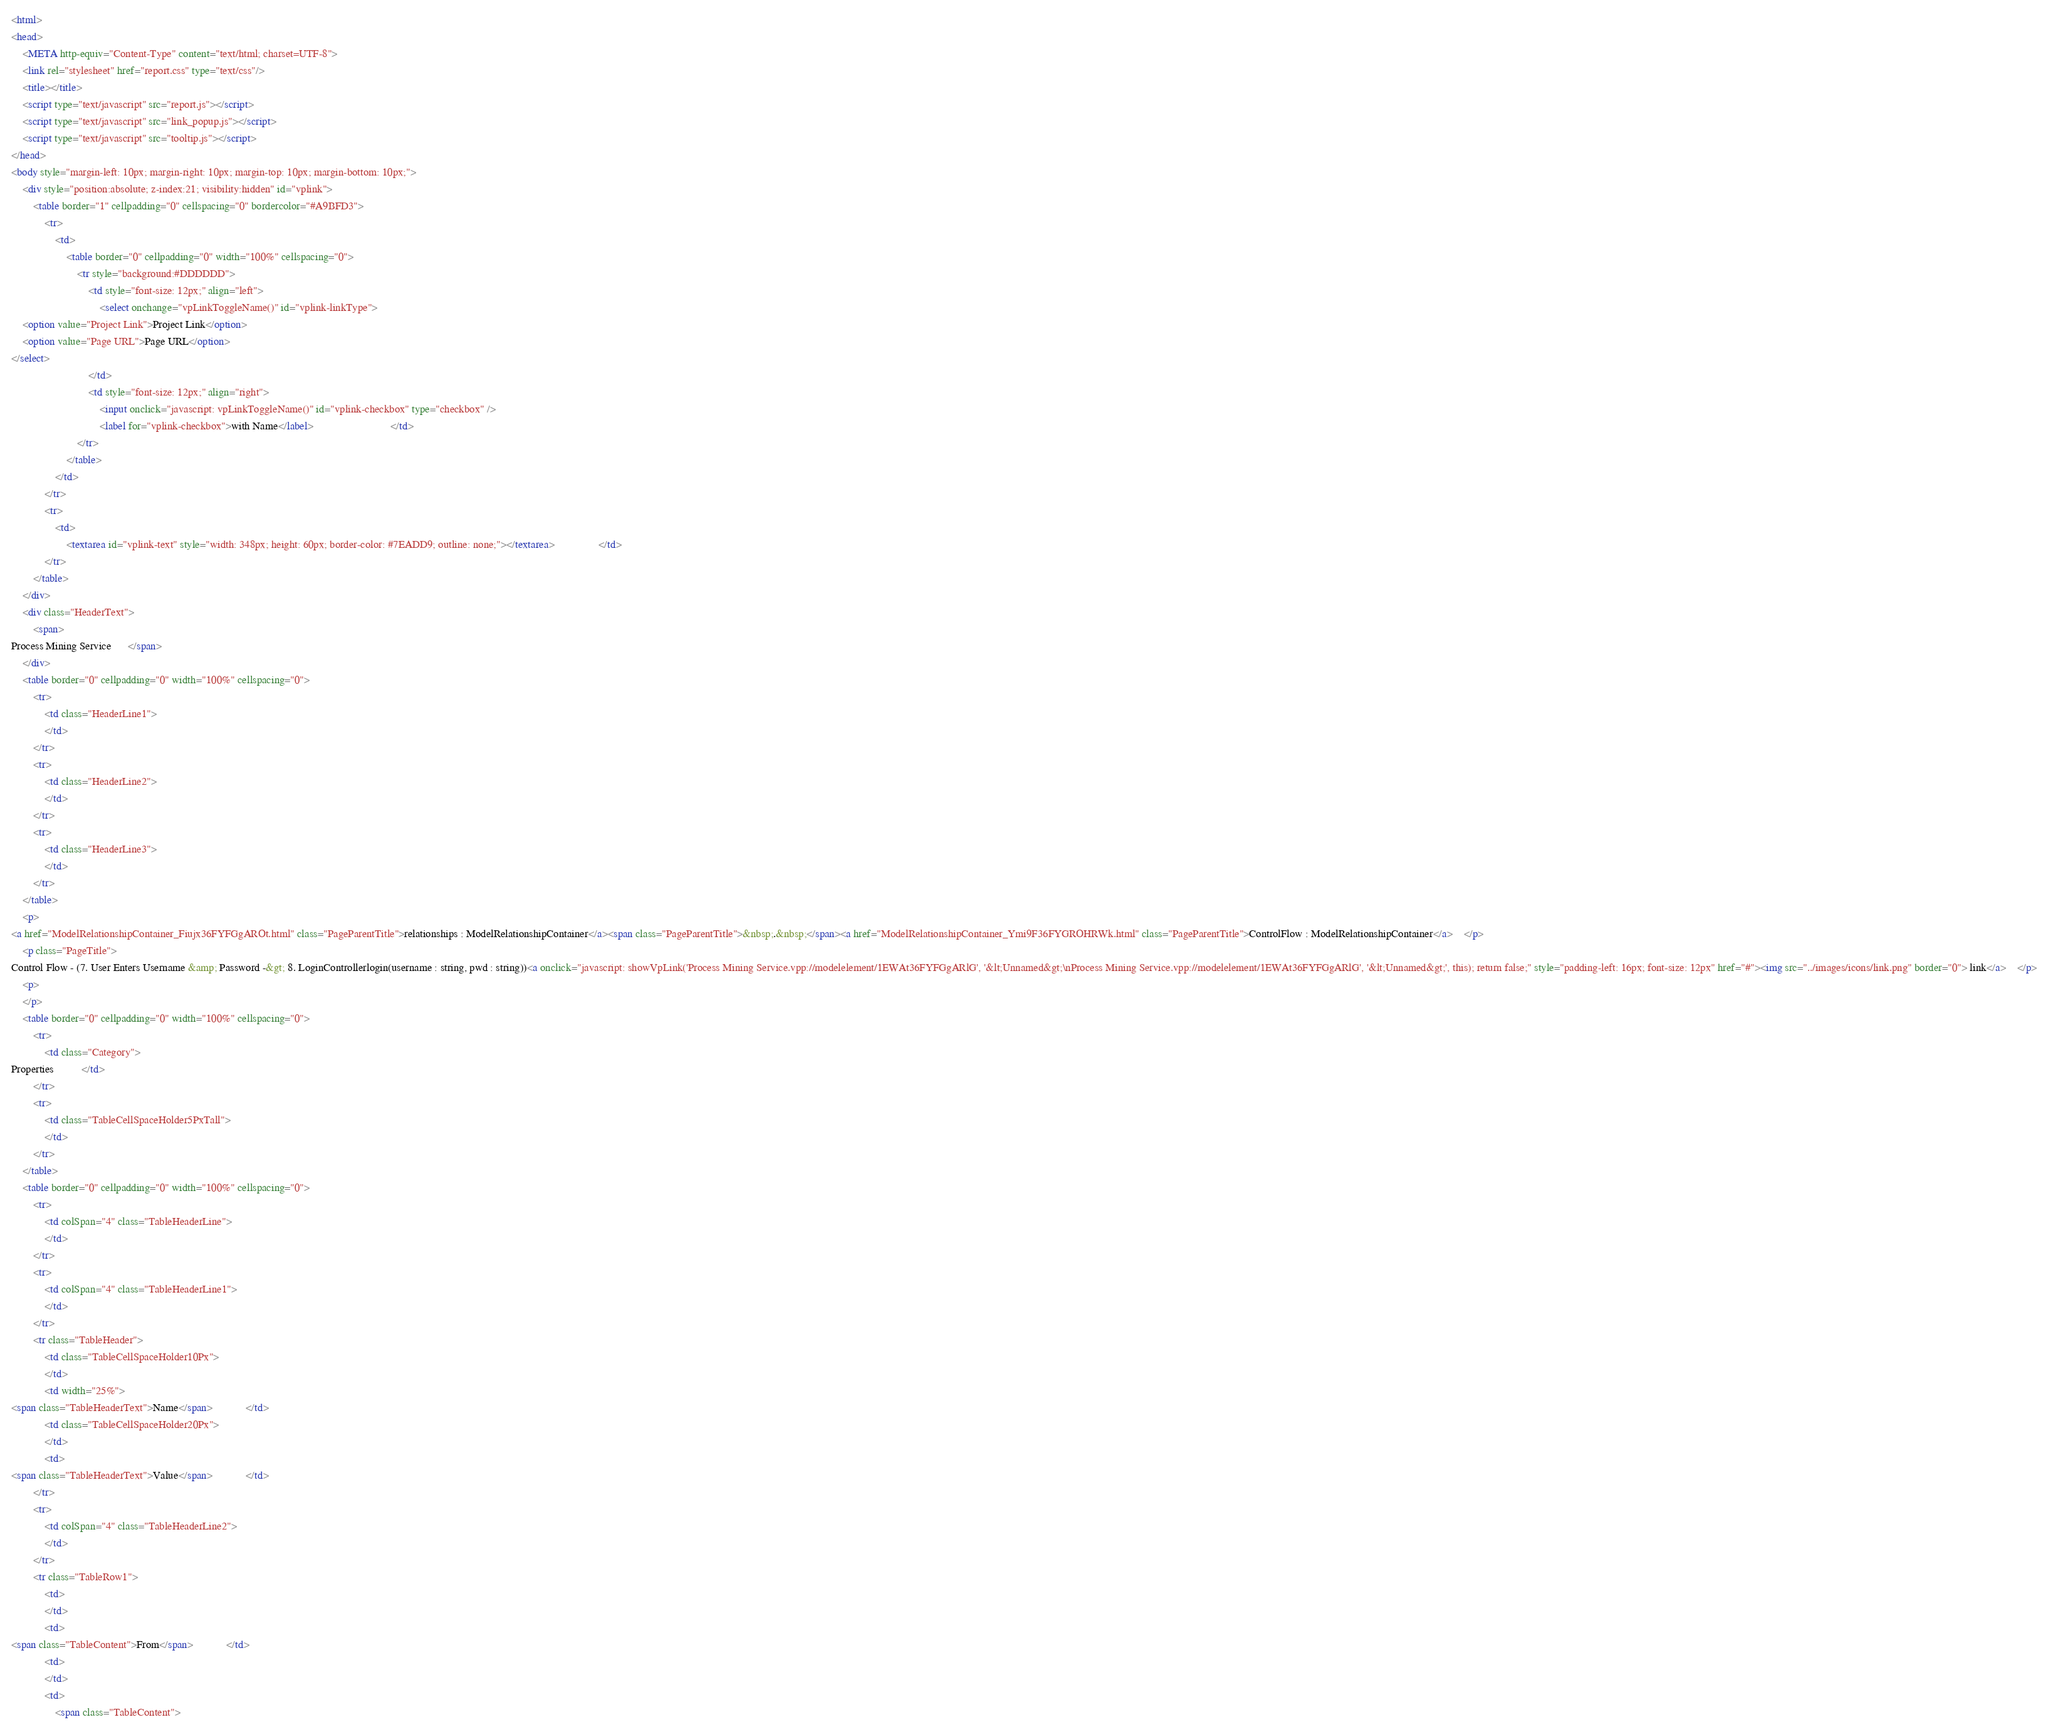Convert code to text. <code><loc_0><loc_0><loc_500><loc_500><_HTML_><html>
<head>
	<META http-equiv="Content-Type" content="text/html; charset=UTF-8">
	<link rel="stylesheet" href="report.css" type="text/css"/>
	<title></title>
	<script type="text/javascript" src="report.js"></script>
	<script type="text/javascript" src="link_popup.js"></script>
	<script type="text/javascript" src="tooltip.js"></script>
</head>
<body style="margin-left: 10px; margin-right: 10px; margin-top: 10px; margin-bottom: 10px;">
	<div style="position:absolute; z-index:21; visibility:hidden" id="vplink">
		<table border="1" cellpadding="0" cellspacing="0" bordercolor="#A9BFD3">
			<tr>
				<td>
					<table border="0" cellpadding="0" width="100%" cellspacing="0">
						<tr style="background:#DDDDDD">
							<td style="font-size: 12px;" align="left">
								<select onchange="vpLinkToggleName()" id="vplink-linkType">
	<option value="Project Link">Project Link</option>
	<option value="Page URL">Page URL</option>
</select>
							</td>
							<td style="font-size: 12px;" align="right">
								<input onclick="javascript: vpLinkToggleName()" id="vplink-checkbox" type="checkbox" />
								<label for="vplink-checkbox">with Name</label>							</td>
						</tr>
					</table>
				</td>
			</tr>
			<tr>
				<td>
					<textarea id="vplink-text" style="width: 348px; height: 60px; border-color: #7EADD9; outline: none;"></textarea>				</td>
			</tr>
		</table>
	</div>
	<div class="HeaderText">
		<span>
Process Mining Service		</span>
	</div>
	<table border="0" cellpadding="0" width="100%" cellspacing="0">
		<tr>
			<td class="HeaderLine1">
			</td>
		</tr>
		<tr>
			<td class="HeaderLine2">
			</td>
		</tr>
		<tr>
			<td class="HeaderLine3">
			</td>
		</tr>
	</table>
	<p>
<a href="ModelRelationshipContainer_Fiujx36FYFGgAROt.html" class="PageParentTitle">relationships : ModelRelationshipContainer</a><span class="PageParentTitle">&nbsp;.&nbsp;</span><a href="ModelRelationshipContainer_Ymi9F36FYGROHRWk.html" class="PageParentTitle">ControlFlow : ModelRelationshipContainer</a>	</p>
	<p class="PageTitle">
Control Flow - (7. User Enters Username &amp; Password -&gt; 8. LoginControllerlogin(username : string, pwd : string))<a onclick="javascript: showVpLink('Process Mining Service.vpp://modelelement/1EWAt36FYFGgARlG', '&lt;Unnamed&gt;\nProcess Mining Service.vpp://modelelement/1EWAt36FYFGgARlG', '&lt;Unnamed&gt;', this); return false;" style="padding-left: 16px; font-size: 12px" href="#"><img src="../images/icons/link.png" border="0"> link</a>	</p>
	<p>
	</p>
	<table border="0" cellpadding="0" width="100%" cellspacing="0">
		<tr>
			<td class="Category">
Properties			</td>
		</tr>
		<tr>
			<td class="TableCellSpaceHolder5PxTall">
			</td>
		</tr>
	</table>
	<table border="0" cellpadding="0" width="100%" cellspacing="0">
		<tr>
			<td colSpan="4" class="TableHeaderLine">
			</td>
		</tr>
		<tr>
			<td colSpan="4" class="TableHeaderLine1">
			</td>
		</tr>
		<tr class="TableHeader">
			<td class="TableCellSpaceHolder10Px">
			</td>
			<td width="25%">
<span class="TableHeaderText">Name</span>			</td>
			<td class="TableCellSpaceHolder20Px">
			</td>
			<td>
<span class="TableHeaderText">Value</span>			</td>
		</tr>
		<tr>
			<td colSpan="4" class="TableHeaderLine2">
			</td>
		</tr>
		<tr class="TableRow1">
			<td>
			</td>
			<td>
<span class="TableContent">From</span>			</td>
			<td>
			</td>
			<td>
				<span class="TableContent"></code> 